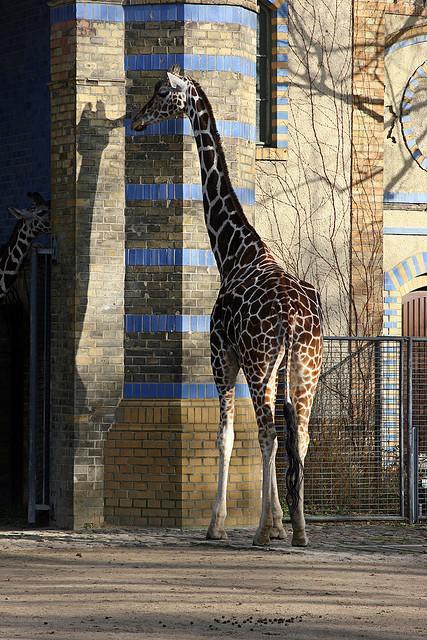How many animals are in the picture?
Give a very brief answer. 1. How many giraffes can you see?
Give a very brief answer. 2. 